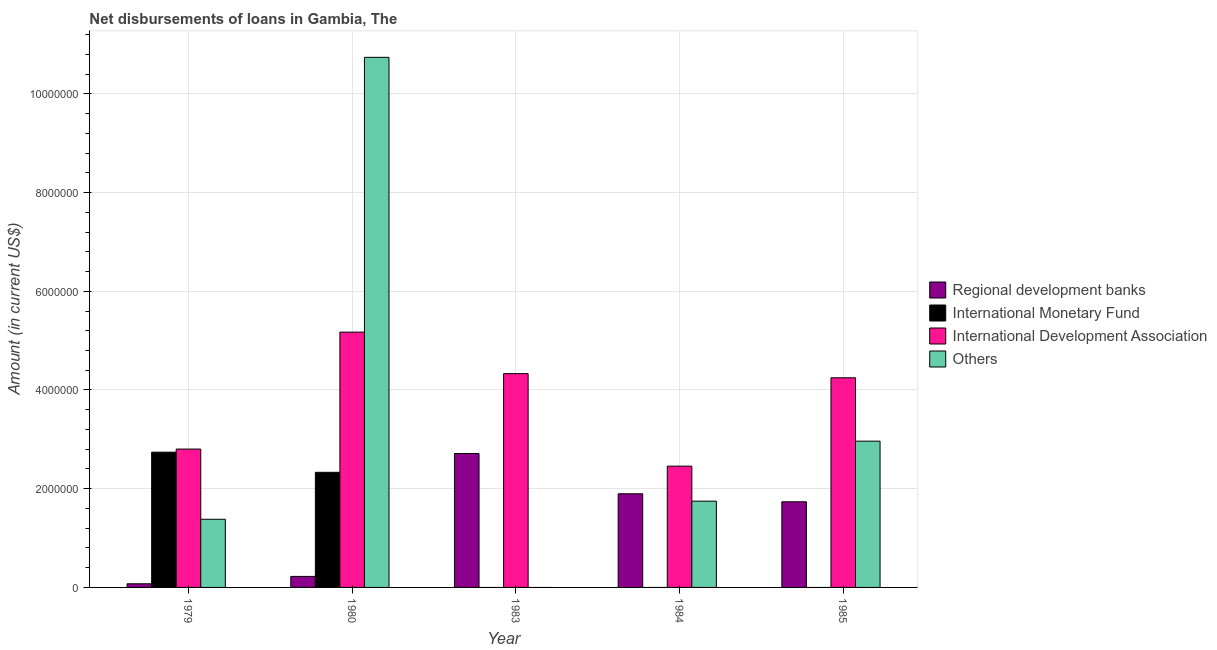How many different coloured bars are there?
Your answer should be very brief. 4. How many groups of bars are there?
Provide a short and direct response. 5. How many bars are there on the 1st tick from the right?
Offer a terse response. 3. What is the label of the 5th group of bars from the left?
Offer a terse response. 1985. In how many cases, is the number of bars for a given year not equal to the number of legend labels?
Offer a very short reply. 3. What is the amount of loan disimbursed by other organisations in 1980?
Keep it short and to the point. 1.07e+07. Across all years, what is the maximum amount of loan disimbursed by other organisations?
Offer a very short reply. 1.07e+07. Across all years, what is the minimum amount of loan disimbursed by regional development banks?
Offer a terse response. 7.40e+04. In which year was the amount of loan disimbursed by international development association maximum?
Your answer should be very brief. 1980. What is the total amount of loan disimbursed by regional development banks in the graph?
Your answer should be compact. 6.64e+06. What is the difference between the amount of loan disimbursed by regional development banks in 1983 and that in 1985?
Keep it short and to the point. 9.78e+05. What is the difference between the amount of loan disimbursed by other organisations in 1985 and the amount of loan disimbursed by international development association in 1983?
Give a very brief answer. 2.96e+06. What is the average amount of loan disimbursed by international monetary fund per year?
Your response must be concise. 1.01e+06. What is the ratio of the amount of loan disimbursed by international development association in 1979 to that in 1984?
Provide a succinct answer. 1.14. Is the amount of loan disimbursed by international development association in 1979 less than that in 1984?
Your answer should be compact. No. Is the difference between the amount of loan disimbursed by international development association in 1983 and 1985 greater than the difference between the amount of loan disimbursed by other organisations in 1983 and 1985?
Offer a very short reply. No. What is the difference between the highest and the second highest amount of loan disimbursed by other organisations?
Give a very brief answer. 7.78e+06. What is the difference between the highest and the lowest amount of loan disimbursed by international development association?
Offer a terse response. 2.72e+06. Is it the case that in every year, the sum of the amount of loan disimbursed by regional development banks and amount of loan disimbursed by international monetary fund is greater than the amount of loan disimbursed by international development association?
Your answer should be compact. No. Are all the bars in the graph horizontal?
Provide a short and direct response. No. Are the values on the major ticks of Y-axis written in scientific E-notation?
Provide a succinct answer. No. Does the graph contain any zero values?
Provide a short and direct response. Yes. Does the graph contain grids?
Provide a succinct answer. Yes. Where does the legend appear in the graph?
Offer a terse response. Center right. How are the legend labels stacked?
Ensure brevity in your answer.  Vertical. What is the title of the graph?
Provide a succinct answer. Net disbursements of loans in Gambia, The. What is the label or title of the X-axis?
Offer a very short reply. Year. What is the Amount (in current US$) in Regional development banks in 1979?
Give a very brief answer. 7.40e+04. What is the Amount (in current US$) in International Monetary Fund in 1979?
Offer a very short reply. 2.74e+06. What is the Amount (in current US$) of International Development Association in 1979?
Offer a very short reply. 2.80e+06. What is the Amount (in current US$) of Others in 1979?
Make the answer very short. 1.38e+06. What is the Amount (in current US$) of Regional development banks in 1980?
Ensure brevity in your answer.  2.23e+05. What is the Amount (in current US$) of International Monetary Fund in 1980?
Offer a very short reply. 2.33e+06. What is the Amount (in current US$) of International Development Association in 1980?
Give a very brief answer. 5.17e+06. What is the Amount (in current US$) of Others in 1980?
Your response must be concise. 1.07e+07. What is the Amount (in current US$) in Regional development banks in 1983?
Provide a short and direct response. 2.71e+06. What is the Amount (in current US$) in International Development Association in 1983?
Keep it short and to the point. 4.33e+06. What is the Amount (in current US$) in Others in 1983?
Keep it short and to the point. 0. What is the Amount (in current US$) of Regional development banks in 1984?
Give a very brief answer. 1.90e+06. What is the Amount (in current US$) of International Monetary Fund in 1984?
Your answer should be compact. 0. What is the Amount (in current US$) of International Development Association in 1984?
Your answer should be compact. 2.46e+06. What is the Amount (in current US$) of Others in 1984?
Give a very brief answer. 1.75e+06. What is the Amount (in current US$) in Regional development banks in 1985?
Keep it short and to the point. 1.74e+06. What is the Amount (in current US$) of International Monetary Fund in 1985?
Your answer should be compact. 0. What is the Amount (in current US$) in International Development Association in 1985?
Make the answer very short. 4.25e+06. What is the Amount (in current US$) in Others in 1985?
Provide a succinct answer. 2.96e+06. Across all years, what is the maximum Amount (in current US$) of Regional development banks?
Your answer should be very brief. 2.71e+06. Across all years, what is the maximum Amount (in current US$) in International Monetary Fund?
Offer a very short reply. 2.74e+06. Across all years, what is the maximum Amount (in current US$) in International Development Association?
Offer a terse response. 5.17e+06. Across all years, what is the maximum Amount (in current US$) of Others?
Your answer should be compact. 1.07e+07. Across all years, what is the minimum Amount (in current US$) in Regional development banks?
Provide a succinct answer. 7.40e+04. Across all years, what is the minimum Amount (in current US$) of International Development Association?
Keep it short and to the point. 2.46e+06. What is the total Amount (in current US$) in Regional development banks in the graph?
Offer a very short reply. 6.64e+06. What is the total Amount (in current US$) of International Monetary Fund in the graph?
Your answer should be compact. 5.07e+06. What is the total Amount (in current US$) of International Development Association in the graph?
Ensure brevity in your answer.  1.90e+07. What is the total Amount (in current US$) in Others in the graph?
Ensure brevity in your answer.  1.68e+07. What is the difference between the Amount (in current US$) in Regional development banks in 1979 and that in 1980?
Give a very brief answer. -1.49e+05. What is the difference between the Amount (in current US$) in International Monetary Fund in 1979 and that in 1980?
Give a very brief answer. 4.08e+05. What is the difference between the Amount (in current US$) in International Development Association in 1979 and that in 1980?
Provide a succinct answer. -2.37e+06. What is the difference between the Amount (in current US$) in Others in 1979 and that in 1980?
Offer a very short reply. -9.36e+06. What is the difference between the Amount (in current US$) in Regional development banks in 1979 and that in 1983?
Offer a terse response. -2.64e+06. What is the difference between the Amount (in current US$) of International Development Association in 1979 and that in 1983?
Give a very brief answer. -1.53e+06. What is the difference between the Amount (in current US$) in Regional development banks in 1979 and that in 1984?
Make the answer very short. -1.82e+06. What is the difference between the Amount (in current US$) of International Development Association in 1979 and that in 1984?
Provide a short and direct response. 3.46e+05. What is the difference between the Amount (in current US$) in Others in 1979 and that in 1984?
Give a very brief answer. -3.67e+05. What is the difference between the Amount (in current US$) in Regional development banks in 1979 and that in 1985?
Offer a terse response. -1.66e+06. What is the difference between the Amount (in current US$) in International Development Association in 1979 and that in 1985?
Provide a short and direct response. -1.44e+06. What is the difference between the Amount (in current US$) in Others in 1979 and that in 1985?
Provide a succinct answer. -1.58e+06. What is the difference between the Amount (in current US$) of Regional development banks in 1980 and that in 1983?
Offer a terse response. -2.49e+06. What is the difference between the Amount (in current US$) in International Development Association in 1980 and that in 1983?
Offer a very short reply. 8.41e+05. What is the difference between the Amount (in current US$) in Regional development banks in 1980 and that in 1984?
Provide a succinct answer. -1.67e+06. What is the difference between the Amount (in current US$) in International Development Association in 1980 and that in 1984?
Offer a terse response. 2.72e+06. What is the difference between the Amount (in current US$) of Others in 1980 and that in 1984?
Give a very brief answer. 8.99e+06. What is the difference between the Amount (in current US$) of Regional development banks in 1980 and that in 1985?
Give a very brief answer. -1.51e+06. What is the difference between the Amount (in current US$) of International Development Association in 1980 and that in 1985?
Provide a succinct answer. 9.25e+05. What is the difference between the Amount (in current US$) in Others in 1980 and that in 1985?
Your response must be concise. 7.78e+06. What is the difference between the Amount (in current US$) of Regional development banks in 1983 and that in 1984?
Provide a short and direct response. 8.16e+05. What is the difference between the Amount (in current US$) in International Development Association in 1983 and that in 1984?
Ensure brevity in your answer.  1.87e+06. What is the difference between the Amount (in current US$) of Regional development banks in 1983 and that in 1985?
Offer a terse response. 9.78e+05. What is the difference between the Amount (in current US$) in International Development Association in 1983 and that in 1985?
Provide a short and direct response. 8.40e+04. What is the difference between the Amount (in current US$) in Regional development banks in 1984 and that in 1985?
Offer a very short reply. 1.62e+05. What is the difference between the Amount (in current US$) of International Development Association in 1984 and that in 1985?
Make the answer very short. -1.79e+06. What is the difference between the Amount (in current US$) in Others in 1984 and that in 1985?
Make the answer very short. -1.22e+06. What is the difference between the Amount (in current US$) in Regional development banks in 1979 and the Amount (in current US$) in International Monetary Fund in 1980?
Offer a very short reply. -2.26e+06. What is the difference between the Amount (in current US$) in Regional development banks in 1979 and the Amount (in current US$) in International Development Association in 1980?
Ensure brevity in your answer.  -5.10e+06. What is the difference between the Amount (in current US$) of Regional development banks in 1979 and the Amount (in current US$) of Others in 1980?
Offer a terse response. -1.07e+07. What is the difference between the Amount (in current US$) of International Monetary Fund in 1979 and the Amount (in current US$) of International Development Association in 1980?
Offer a terse response. -2.43e+06. What is the difference between the Amount (in current US$) of International Monetary Fund in 1979 and the Amount (in current US$) of Others in 1980?
Make the answer very short. -8.00e+06. What is the difference between the Amount (in current US$) in International Development Association in 1979 and the Amount (in current US$) in Others in 1980?
Provide a short and direct response. -7.94e+06. What is the difference between the Amount (in current US$) in Regional development banks in 1979 and the Amount (in current US$) in International Development Association in 1983?
Offer a terse response. -4.26e+06. What is the difference between the Amount (in current US$) in International Monetary Fund in 1979 and the Amount (in current US$) in International Development Association in 1983?
Make the answer very short. -1.59e+06. What is the difference between the Amount (in current US$) in Regional development banks in 1979 and the Amount (in current US$) in International Development Association in 1984?
Your answer should be compact. -2.38e+06. What is the difference between the Amount (in current US$) in Regional development banks in 1979 and the Amount (in current US$) in Others in 1984?
Your answer should be compact. -1.67e+06. What is the difference between the Amount (in current US$) in International Monetary Fund in 1979 and the Amount (in current US$) in International Development Association in 1984?
Your answer should be compact. 2.83e+05. What is the difference between the Amount (in current US$) in International Monetary Fund in 1979 and the Amount (in current US$) in Others in 1984?
Your answer should be very brief. 9.92e+05. What is the difference between the Amount (in current US$) of International Development Association in 1979 and the Amount (in current US$) of Others in 1984?
Keep it short and to the point. 1.06e+06. What is the difference between the Amount (in current US$) in Regional development banks in 1979 and the Amount (in current US$) in International Development Association in 1985?
Make the answer very short. -4.17e+06. What is the difference between the Amount (in current US$) in Regional development banks in 1979 and the Amount (in current US$) in Others in 1985?
Provide a succinct answer. -2.89e+06. What is the difference between the Amount (in current US$) in International Monetary Fund in 1979 and the Amount (in current US$) in International Development Association in 1985?
Give a very brief answer. -1.51e+06. What is the difference between the Amount (in current US$) in International Monetary Fund in 1979 and the Amount (in current US$) in Others in 1985?
Keep it short and to the point. -2.23e+05. What is the difference between the Amount (in current US$) in Regional development banks in 1980 and the Amount (in current US$) in International Development Association in 1983?
Your answer should be very brief. -4.11e+06. What is the difference between the Amount (in current US$) in International Monetary Fund in 1980 and the Amount (in current US$) in International Development Association in 1983?
Give a very brief answer. -2.00e+06. What is the difference between the Amount (in current US$) of Regional development banks in 1980 and the Amount (in current US$) of International Development Association in 1984?
Offer a terse response. -2.23e+06. What is the difference between the Amount (in current US$) of Regional development banks in 1980 and the Amount (in current US$) of Others in 1984?
Offer a terse response. -1.52e+06. What is the difference between the Amount (in current US$) in International Monetary Fund in 1980 and the Amount (in current US$) in International Development Association in 1984?
Provide a short and direct response. -1.25e+05. What is the difference between the Amount (in current US$) in International Monetary Fund in 1980 and the Amount (in current US$) in Others in 1984?
Your response must be concise. 5.84e+05. What is the difference between the Amount (in current US$) in International Development Association in 1980 and the Amount (in current US$) in Others in 1984?
Offer a terse response. 3.42e+06. What is the difference between the Amount (in current US$) in Regional development banks in 1980 and the Amount (in current US$) in International Development Association in 1985?
Your answer should be very brief. -4.02e+06. What is the difference between the Amount (in current US$) of Regional development banks in 1980 and the Amount (in current US$) of Others in 1985?
Ensure brevity in your answer.  -2.74e+06. What is the difference between the Amount (in current US$) in International Monetary Fund in 1980 and the Amount (in current US$) in International Development Association in 1985?
Provide a short and direct response. -1.92e+06. What is the difference between the Amount (in current US$) of International Monetary Fund in 1980 and the Amount (in current US$) of Others in 1985?
Make the answer very short. -6.31e+05. What is the difference between the Amount (in current US$) of International Development Association in 1980 and the Amount (in current US$) of Others in 1985?
Offer a very short reply. 2.21e+06. What is the difference between the Amount (in current US$) in Regional development banks in 1983 and the Amount (in current US$) in International Development Association in 1984?
Make the answer very short. 2.56e+05. What is the difference between the Amount (in current US$) of Regional development banks in 1983 and the Amount (in current US$) of Others in 1984?
Your response must be concise. 9.65e+05. What is the difference between the Amount (in current US$) in International Development Association in 1983 and the Amount (in current US$) in Others in 1984?
Your response must be concise. 2.58e+06. What is the difference between the Amount (in current US$) in Regional development banks in 1983 and the Amount (in current US$) in International Development Association in 1985?
Provide a succinct answer. -1.53e+06. What is the difference between the Amount (in current US$) in Regional development banks in 1983 and the Amount (in current US$) in Others in 1985?
Make the answer very short. -2.50e+05. What is the difference between the Amount (in current US$) in International Development Association in 1983 and the Amount (in current US$) in Others in 1985?
Offer a very short reply. 1.37e+06. What is the difference between the Amount (in current US$) in Regional development banks in 1984 and the Amount (in current US$) in International Development Association in 1985?
Your answer should be compact. -2.35e+06. What is the difference between the Amount (in current US$) of Regional development banks in 1984 and the Amount (in current US$) of Others in 1985?
Make the answer very short. -1.07e+06. What is the difference between the Amount (in current US$) of International Development Association in 1984 and the Amount (in current US$) of Others in 1985?
Offer a very short reply. -5.06e+05. What is the average Amount (in current US$) in Regional development banks per year?
Provide a succinct answer. 1.33e+06. What is the average Amount (in current US$) in International Monetary Fund per year?
Offer a very short reply. 1.01e+06. What is the average Amount (in current US$) of International Development Association per year?
Provide a succinct answer. 3.80e+06. What is the average Amount (in current US$) in Others per year?
Ensure brevity in your answer.  3.37e+06. In the year 1979, what is the difference between the Amount (in current US$) of Regional development banks and Amount (in current US$) of International Monetary Fund?
Offer a terse response. -2.67e+06. In the year 1979, what is the difference between the Amount (in current US$) in Regional development banks and Amount (in current US$) in International Development Association?
Your answer should be compact. -2.73e+06. In the year 1979, what is the difference between the Amount (in current US$) in Regional development banks and Amount (in current US$) in Others?
Make the answer very short. -1.31e+06. In the year 1979, what is the difference between the Amount (in current US$) of International Monetary Fund and Amount (in current US$) of International Development Association?
Keep it short and to the point. -6.30e+04. In the year 1979, what is the difference between the Amount (in current US$) of International Monetary Fund and Amount (in current US$) of Others?
Keep it short and to the point. 1.36e+06. In the year 1979, what is the difference between the Amount (in current US$) of International Development Association and Amount (in current US$) of Others?
Your answer should be compact. 1.42e+06. In the year 1980, what is the difference between the Amount (in current US$) of Regional development banks and Amount (in current US$) of International Monetary Fund?
Provide a short and direct response. -2.11e+06. In the year 1980, what is the difference between the Amount (in current US$) of Regional development banks and Amount (in current US$) of International Development Association?
Keep it short and to the point. -4.95e+06. In the year 1980, what is the difference between the Amount (in current US$) in Regional development banks and Amount (in current US$) in Others?
Your answer should be very brief. -1.05e+07. In the year 1980, what is the difference between the Amount (in current US$) of International Monetary Fund and Amount (in current US$) of International Development Association?
Keep it short and to the point. -2.84e+06. In the year 1980, what is the difference between the Amount (in current US$) of International Monetary Fund and Amount (in current US$) of Others?
Give a very brief answer. -8.41e+06. In the year 1980, what is the difference between the Amount (in current US$) in International Development Association and Amount (in current US$) in Others?
Ensure brevity in your answer.  -5.57e+06. In the year 1983, what is the difference between the Amount (in current US$) of Regional development banks and Amount (in current US$) of International Development Association?
Make the answer very short. -1.62e+06. In the year 1984, what is the difference between the Amount (in current US$) in Regional development banks and Amount (in current US$) in International Development Association?
Provide a succinct answer. -5.60e+05. In the year 1984, what is the difference between the Amount (in current US$) in Regional development banks and Amount (in current US$) in Others?
Provide a succinct answer. 1.49e+05. In the year 1984, what is the difference between the Amount (in current US$) of International Development Association and Amount (in current US$) of Others?
Ensure brevity in your answer.  7.09e+05. In the year 1985, what is the difference between the Amount (in current US$) in Regional development banks and Amount (in current US$) in International Development Association?
Give a very brief answer. -2.51e+06. In the year 1985, what is the difference between the Amount (in current US$) of Regional development banks and Amount (in current US$) of Others?
Ensure brevity in your answer.  -1.23e+06. In the year 1985, what is the difference between the Amount (in current US$) in International Development Association and Amount (in current US$) in Others?
Keep it short and to the point. 1.28e+06. What is the ratio of the Amount (in current US$) of Regional development banks in 1979 to that in 1980?
Give a very brief answer. 0.33. What is the ratio of the Amount (in current US$) of International Monetary Fund in 1979 to that in 1980?
Keep it short and to the point. 1.18. What is the ratio of the Amount (in current US$) of International Development Association in 1979 to that in 1980?
Provide a succinct answer. 0.54. What is the ratio of the Amount (in current US$) of Others in 1979 to that in 1980?
Offer a very short reply. 0.13. What is the ratio of the Amount (in current US$) in Regional development banks in 1979 to that in 1983?
Your answer should be very brief. 0.03. What is the ratio of the Amount (in current US$) in International Development Association in 1979 to that in 1983?
Your answer should be very brief. 0.65. What is the ratio of the Amount (in current US$) in Regional development banks in 1979 to that in 1984?
Make the answer very short. 0.04. What is the ratio of the Amount (in current US$) in International Development Association in 1979 to that in 1984?
Your response must be concise. 1.14. What is the ratio of the Amount (in current US$) of Others in 1979 to that in 1984?
Provide a short and direct response. 0.79. What is the ratio of the Amount (in current US$) in Regional development banks in 1979 to that in 1985?
Ensure brevity in your answer.  0.04. What is the ratio of the Amount (in current US$) in International Development Association in 1979 to that in 1985?
Ensure brevity in your answer.  0.66. What is the ratio of the Amount (in current US$) in Others in 1979 to that in 1985?
Give a very brief answer. 0.47. What is the ratio of the Amount (in current US$) in Regional development banks in 1980 to that in 1983?
Offer a terse response. 0.08. What is the ratio of the Amount (in current US$) in International Development Association in 1980 to that in 1983?
Provide a succinct answer. 1.19. What is the ratio of the Amount (in current US$) in Regional development banks in 1980 to that in 1984?
Provide a short and direct response. 0.12. What is the ratio of the Amount (in current US$) of International Development Association in 1980 to that in 1984?
Keep it short and to the point. 2.1. What is the ratio of the Amount (in current US$) in Others in 1980 to that in 1984?
Your response must be concise. 6.14. What is the ratio of the Amount (in current US$) in Regional development banks in 1980 to that in 1985?
Your answer should be very brief. 0.13. What is the ratio of the Amount (in current US$) in International Development Association in 1980 to that in 1985?
Give a very brief answer. 1.22. What is the ratio of the Amount (in current US$) in Others in 1980 to that in 1985?
Give a very brief answer. 3.62. What is the ratio of the Amount (in current US$) in Regional development banks in 1983 to that in 1984?
Offer a very short reply. 1.43. What is the ratio of the Amount (in current US$) of International Development Association in 1983 to that in 1984?
Give a very brief answer. 1.76. What is the ratio of the Amount (in current US$) of Regional development banks in 1983 to that in 1985?
Provide a short and direct response. 1.56. What is the ratio of the Amount (in current US$) of International Development Association in 1983 to that in 1985?
Make the answer very short. 1.02. What is the ratio of the Amount (in current US$) of Regional development banks in 1984 to that in 1985?
Provide a succinct answer. 1.09. What is the ratio of the Amount (in current US$) of International Development Association in 1984 to that in 1985?
Provide a succinct answer. 0.58. What is the ratio of the Amount (in current US$) in Others in 1984 to that in 1985?
Keep it short and to the point. 0.59. What is the difference between the highest and the second highest Amount (in current US$) of Regional development banks?
Keep it short and to the point. 8.16e+05. What is the difference between the highest and the second highest Amount (in current US$) of International Development Association?
Keep it short and to the point. 8.41e+05. What is the difference between the highest and the second highest Amount (in current US$) of Others?
Your answer should be compact. 7.78e+06. What is the difference between the highest and the lowest Amount (in current US$) of Regional development banks?
Your response must be concise. 2.64e+06. What is the difference between the highest and the lowest Amount (in current US$) in International Monetary Fund?
Provide a short and direct response. 2.74e+06. What is the difference between the highest and the lowest Amount (in current US$) of International Development Association?
Provide a short and direct response. 2.72e+06. What is the difference between the highest and the lowest Amount (in current US$) in Others?
Your answer should be compact. 1.07e+07. 